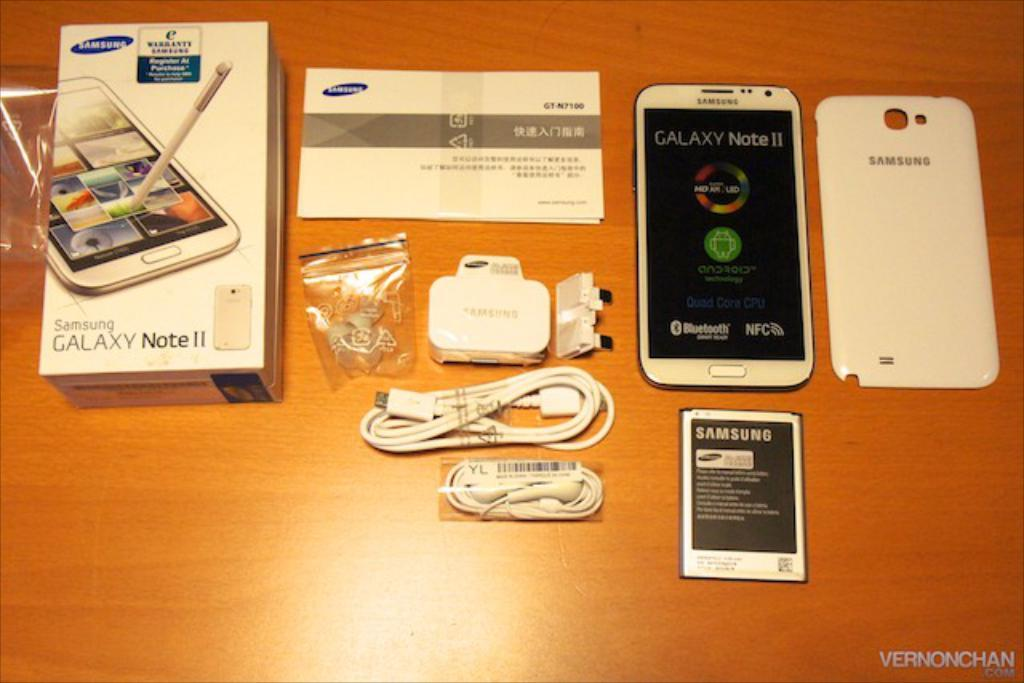<image>
Create a compact narrative representing the image presented. Samsung Galaxy phone displayed on a table with all the components spread out. 